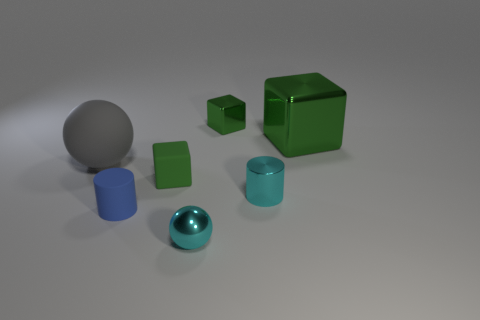How many gray spheres are in front of the tiny green block in front of the large gray matte ball?
Keep it short and to the point. 0. Is there a shiny thing of the same shape as the big gray rubber thing?
Provide a succinct answer. Yes. Is the size of the cyan thing on the left side of the cyan cylinder the same as the ball behind the cyan metal cylinder?
Offer a terse response. No. What is the shape of the rubber object that is in front of the green object that is in front of the large gray rubber object?
Provide a short and direct response. Cylinder. What number of cyan objects have the same size as the rubber sphere?
Offer a very short reply. 0. Is there a blue metal thing?
Offer a terse response. No. Are there any other things of the same color as the small shiny ball?
Make the answer very short. Yes. There is a big green object that is made of the same material as the tiny cyan sphere; what is its shape?
Your answer should be very brief. Cube. What color is the tiny block behind the green metallic cube to the right of the tiny green block behind the large gray rubber object?
Ensure brevity in your answer.  Green. Is the number of large green things on the left side of the tiny cyan metal cylinder the same as the number of gray spheres?
Ensure brevity in your answer.  No. 